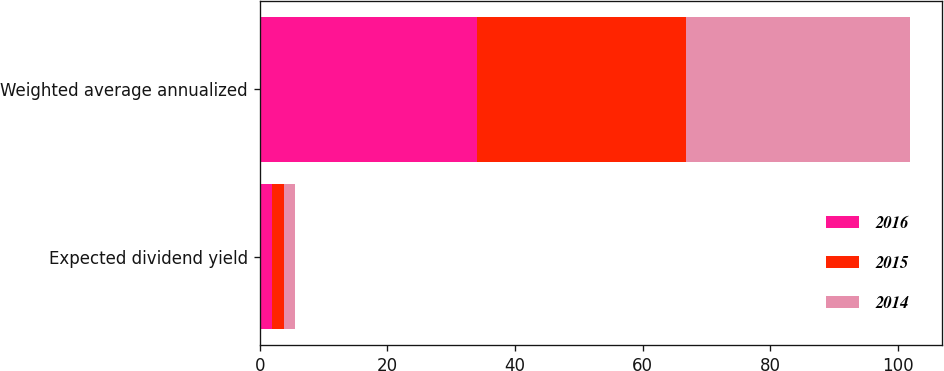Convert chart. <chart><loc_0><loc_0><loc_500><loc_500><stacked_bar_chart><ecel><fcel>Expected dividend yield<fcel>Weighted average annualized<nl><fcel>2016<fcel>2<fcel>34.1<nl><fcel>2015<fcel>1.8<fcel>32.7<nl><fcel>2014<fcel>1.7<fcel>35.1<nl></chart> 